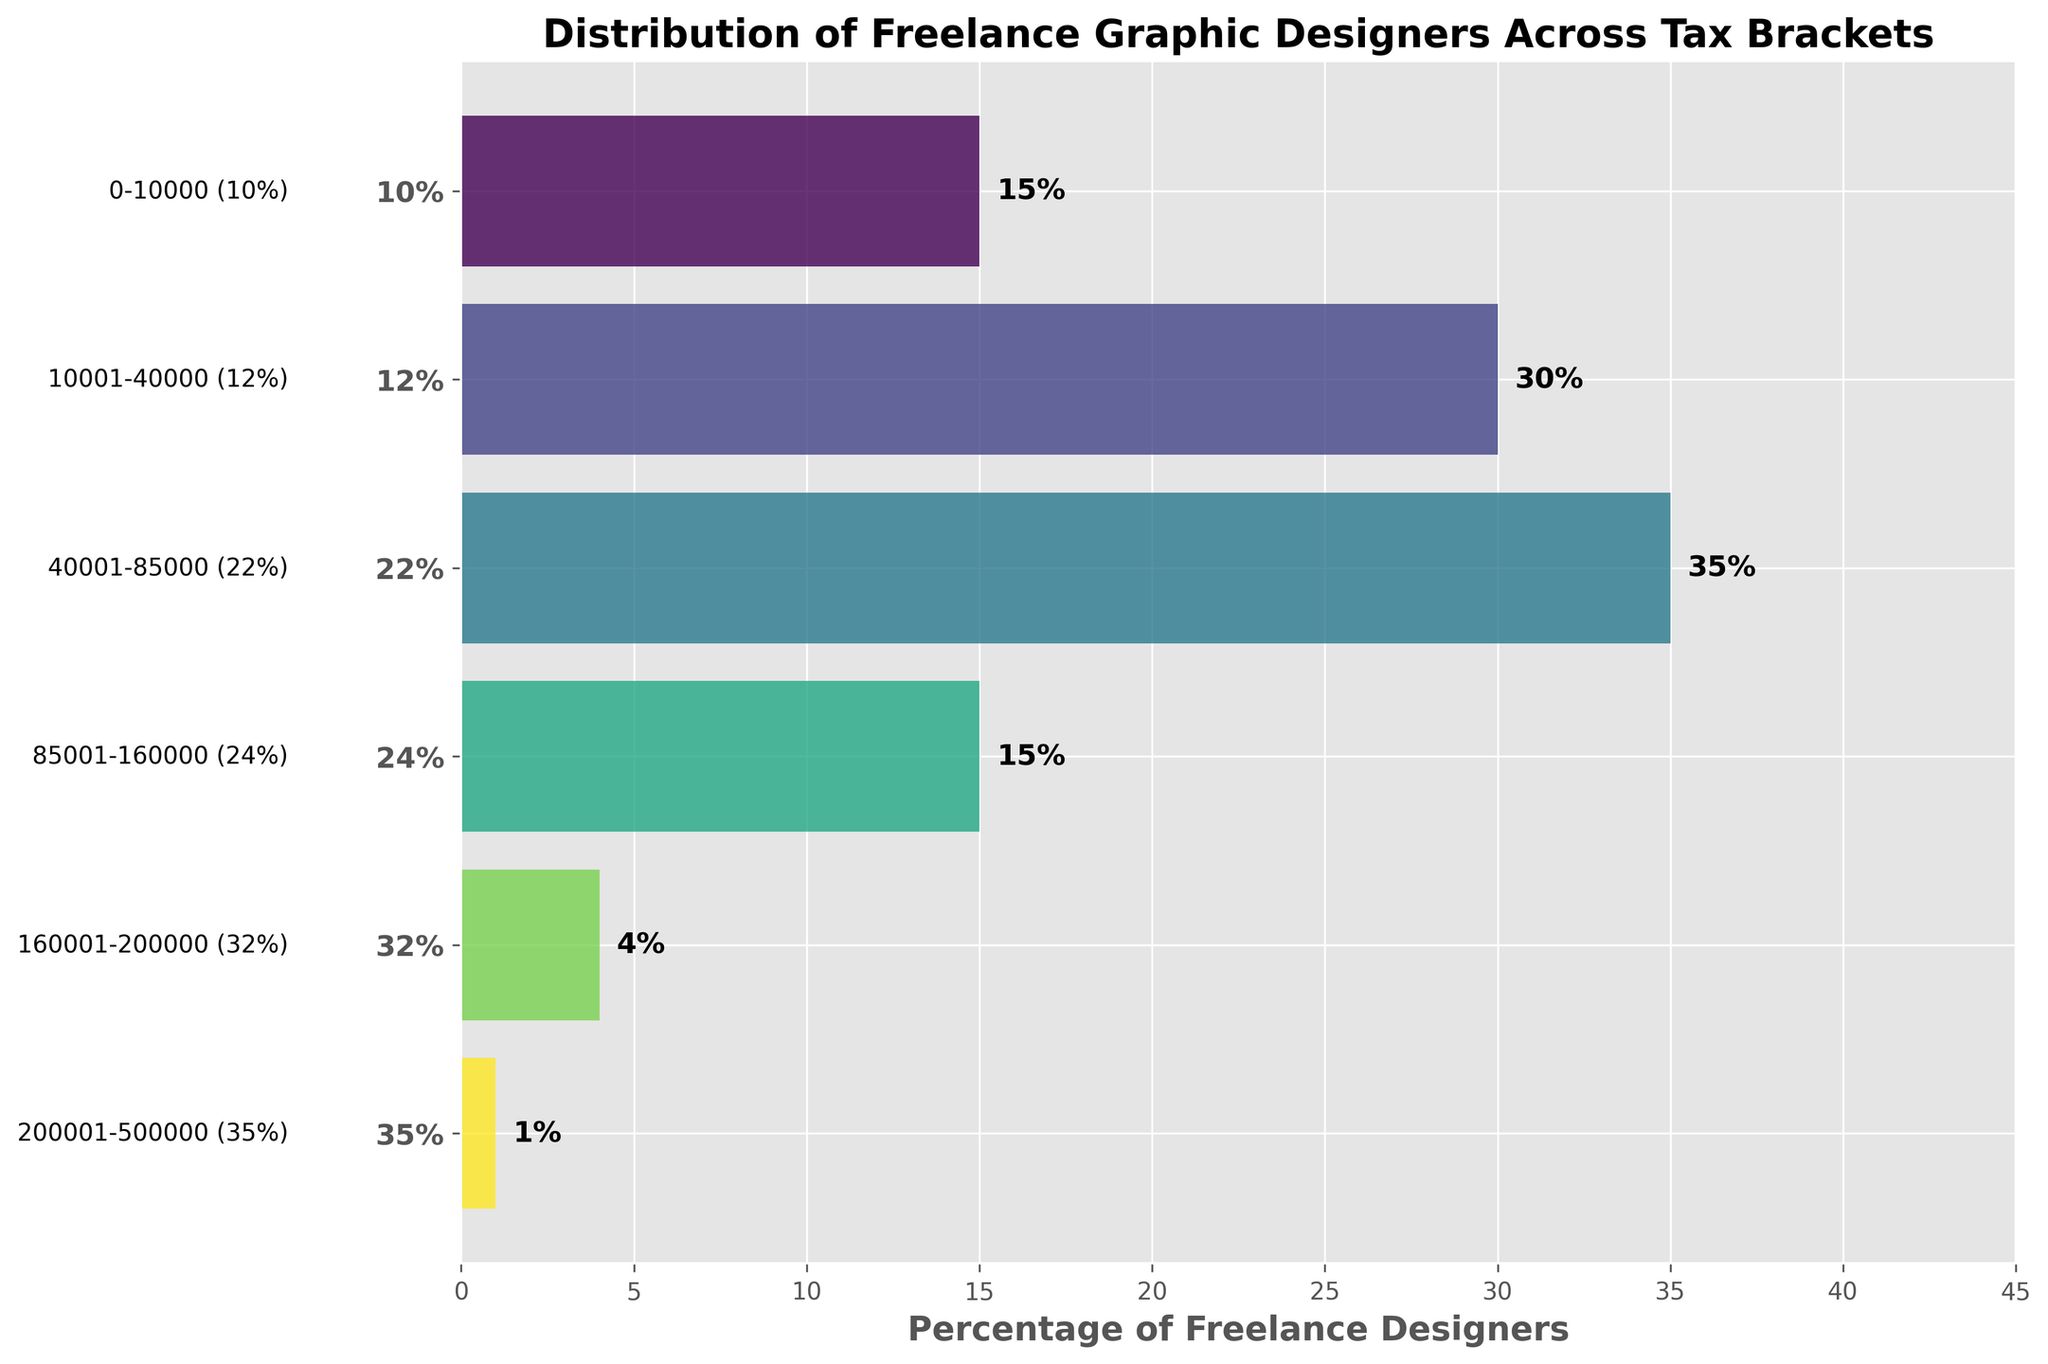What is the title of the plot? The title is displayed at the top of the figure in a larger font size. It reads "Distribution of Freelance Graphic Designers Across Tax Brackets."
Answer: Distribution of Freelance Graphic Designers Across Tax Brackets Which tax bracket has the highest percentage of freelance designers? The tax bracket with the highest percentage can be identified by looking for the longest bar on the horizontal axis. The 22% tax bracket is the longest bar, indicating the highest percentage.
Answer: 22% How many tax brackets are represented in the plot? Count the number of unique tax brackets listed along the vertical axis. There are six tax brackets indicated by the bars on the plot.
Answer: 6 What is the combined percentage of freelance designers in the 10%, 12%, and 22% tax brackets? Add the percentages of freelance designers in the 10%, 12%, and 22% tax brackets: 15% + 30% + 35% = 80%.
Answer: 80% How does the percentage of designers in the 32% tax bracket compare to the 24% tax bracket? Compare the lengths of the bars for the 32% and 24% tax brackets. The bar for the 32% tax bracket is shorter, indicating a smaller percentage (4%) compared to the 24% tax bracket (15%).
Answer: The 32% tax bracket has a smaller percentage What income range corresponds to the 12% tax bracket? The income range is labeled next to each bar on the plot. For the 12% tax bracket, the income range is 10001-40000.
Answer: 10001-40000 Which tax bracket has the smallest percentage of freelance designers? Look for the shortest bar indicating the smallest percentage. The 35% tax bracket, with a percentage of 1%, is the smallest.
Answer: 35% What is the difference in percentage between the tax brackets with the highest and lowest percentages? Find the highest percentage (35% in the 22% tax bracket) and the lowest percentage (1% in the 35% tax bracket). Subtract the lowest from the highest: 35% - 1% = 34%.
Answer: 34% What is the combined percentage of freelance designers in the 24% and 32% tax brackets? Add the percentages for the 24% and 32% tax brackets: 15% + 4% = 19%.
Answer: 19% Which tax bracket covering income above $200000 has the smallest percentage of freelance designers? Identify the tax brackets covering incomes above $200000. The brackets covering such incomes are 35%. Among these, the 35% tax bracket has the smallest percentage, which is 1%.
Answer: 35% 